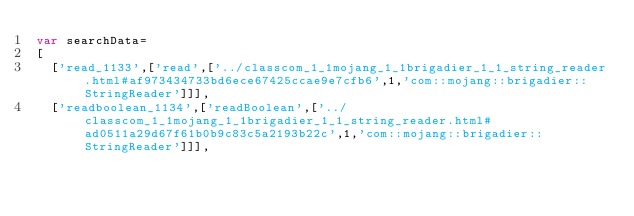<code> <loc_0><loc_0><loc_500><loc_500><_JavaScript_>var searchData=
[
  ['read_1133',['read',['../classcom_1_1mojang_1_1brigadier_1_1_string_reader.html#af973434733bd6ece67425ccae9e7cfb6',1,'com::mojang::brigadier::StringReader']]],
  ['readboolean_1134',['readBoolean',['../classcom_1_1mojang_1_1brigadier_1_1_string_reader.html#ad0511a29d67f61b0b9c83c5a2193b22c',1,'com::mojang::brigadier::StringReader']]],</code> 